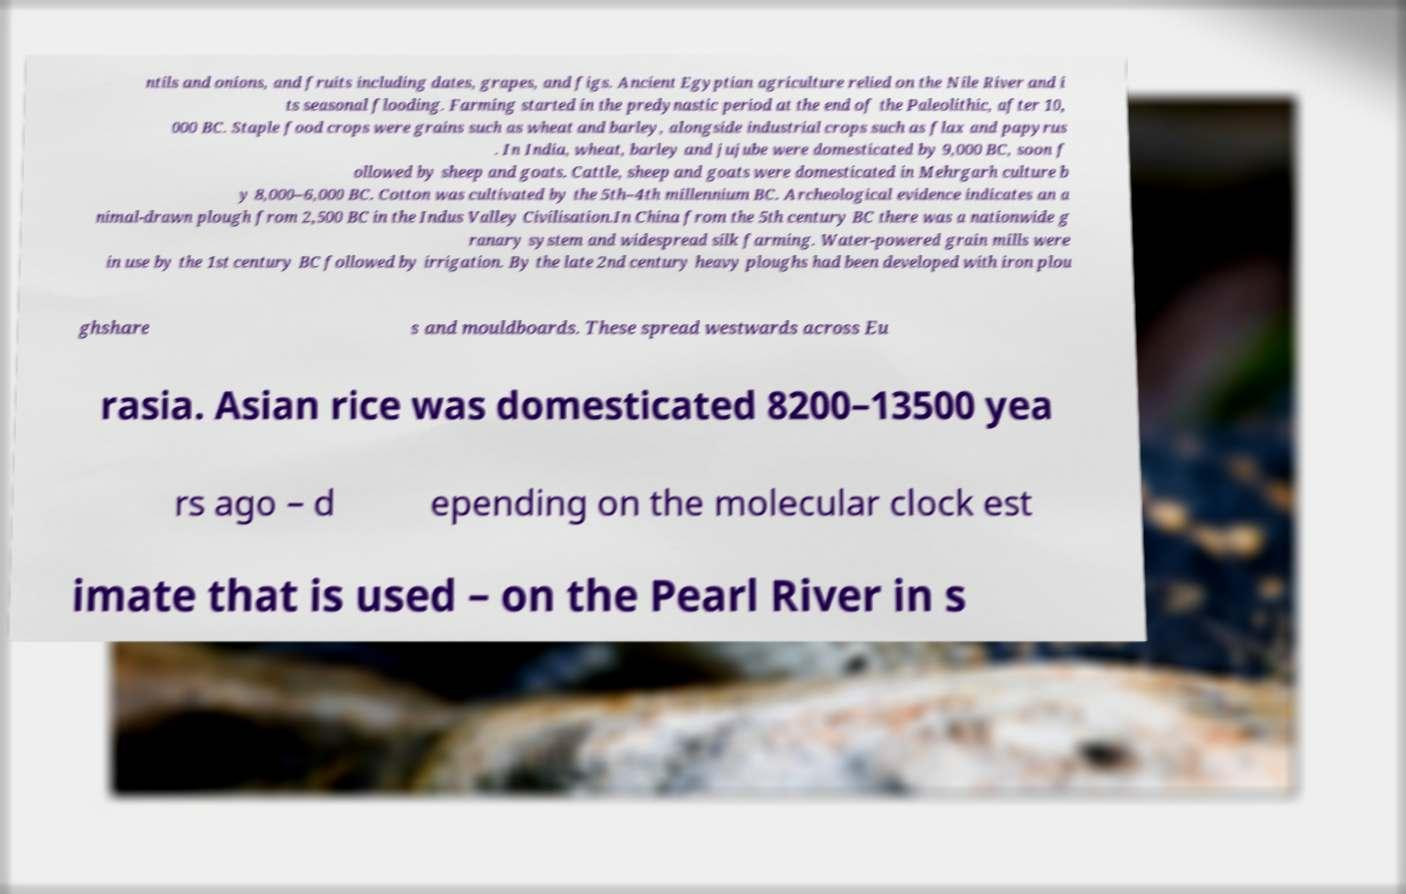What messages or text are displayed in this image? I need them in a readable, typed format. ntils and onions, and fruits including dates, grapes, and figs. Ancient Egyptian agriculture relied on the Nile River and i ts seasonal flooding. Farming started in the predynastic period at the end of the Paleolithic, after 10, 000 BC. Staple food crops were grains such as wheat and barley, alongside industrial crops such as flax and papyrus . In India, wheat, barley and jujube were domesticated by 9,000 BC, soon f ollowed by sheep and goats. Cattle, sheep and goats were domesticated in Mehrgarh culture b y 8,000–6,000 BC. Cotton was cultivated by the 5th–4th millennium BC. Archeological evidence indicates an a nimal-drawn plough from 2,500 BC in the Indus Valley Civilisation.In China from the 5th century BC there was a nationwide g ranary system and widespread silk farming. Water-powered grain mills were in use by the 1st century BC followed by irrigation. By the late 2nd century heavy ploughs had been developed with iron plou ghshare s and mouldboards. These spread westwards across Eu rasia. Asian rice was domesticated 8200–13500 yea rs ago – d epending on the molecular clock est imate that is used – on the Pearl River in s 